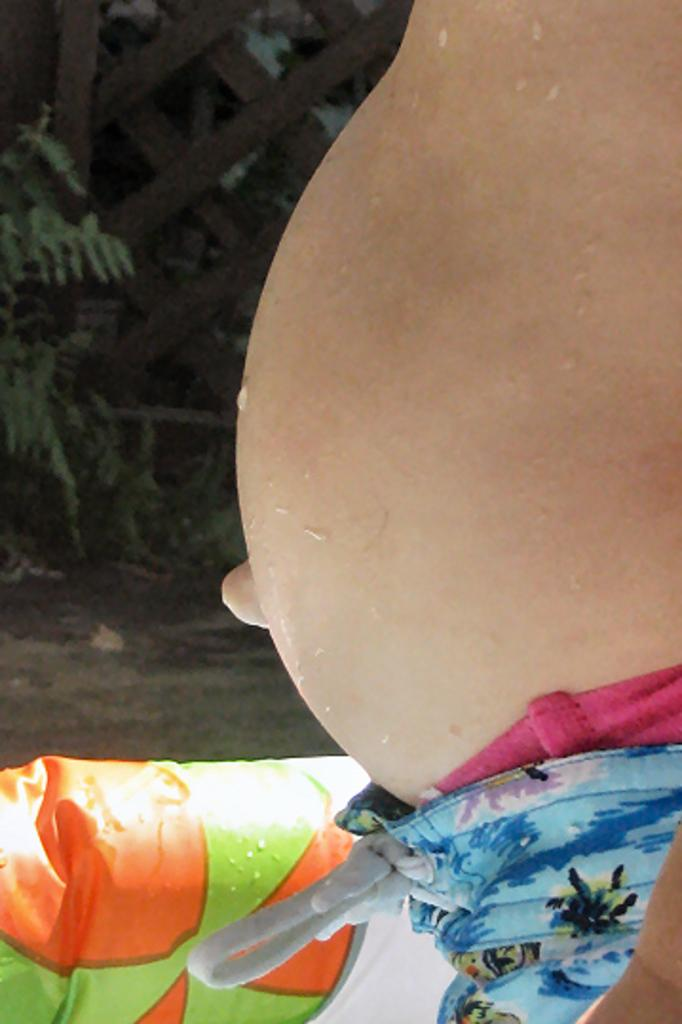What part of a person's body is visible in the image? There is a person's belly visible in the image. What object is present for cooking or grilling? There is a wooden grill in the image. What type of vegetation can be seen in the image? There are plants in the image. What surface is visible beneath the person and the grill? The ground is visible in the image. What arithmetic problem is being solved on the person's belly in the image? There is no arithmetic problem visible on the person's belly in the image. 